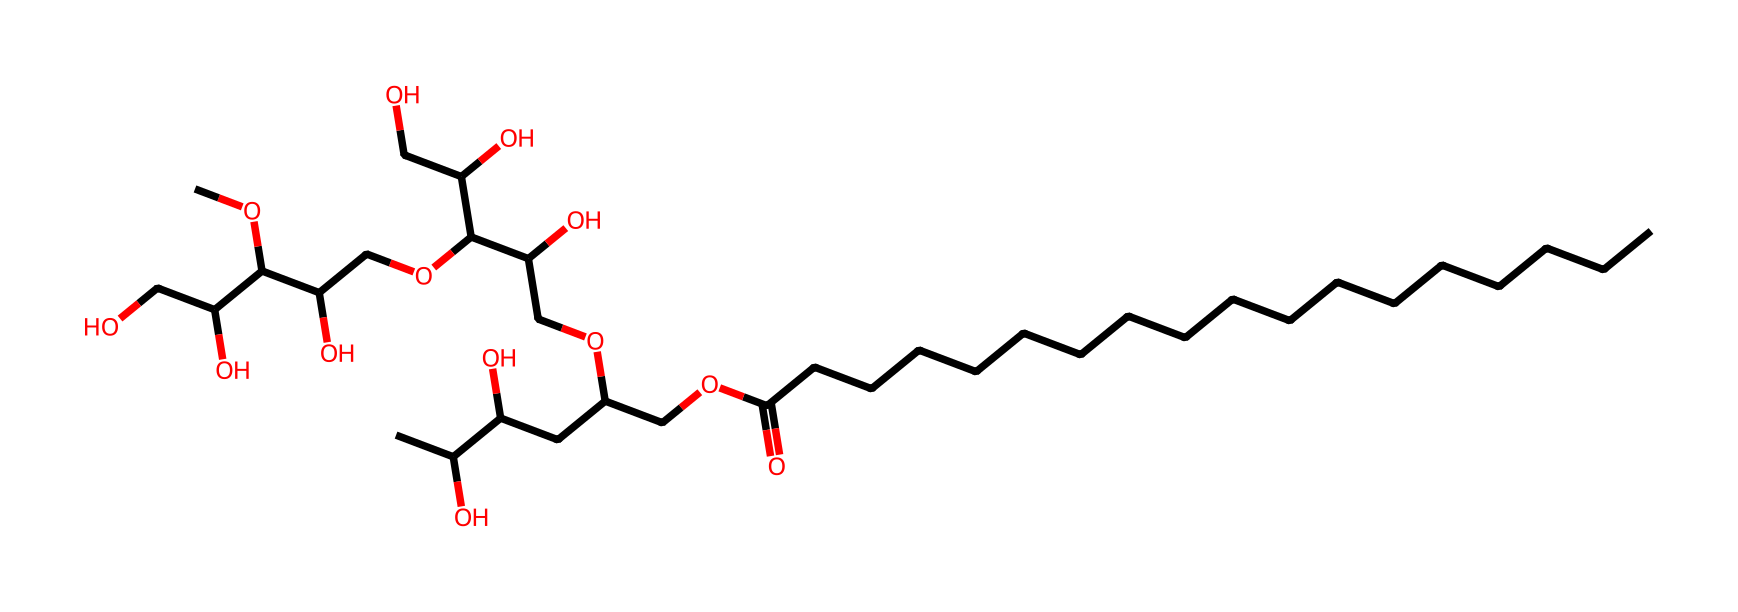What is the molecular formula of polysorbate 80? By analyzing the given SMILES string and accounting for every element present in the structure, we can deduce the molecular formula. The SMILES indicates multiple carbon (C), hydrogen (H), and oxygen (O) atoms throughout. In this case, summing up these atoms gives the final molecular formula C24H44O18.
Answer: C24H44O18 How many ester bonds are present in the structure? The structure of polysorbate 80 contains esters formed between the fatty acid and the glycerol components. By reviewing the SMILES, each segment of the ether linkages (O) in the structure indicates an ester bond. There are 4 ester linkages present.
Answer: 4 What is the primary function of polysorbate 80 in infant formula? Polysorbate 80 is primarily used as an emulsifier in food products, helping to stabilize mixtures of oil and water. This specific function is crucial in infant formula to ensure uniform distribution and absorption of nutrients.
Answer: emulsifier How many carbon atoms are in the longest carbon chain of polysorbate 80? The longest carbon chain can be identified by tracing continuous carbon atoms in the SMILES representation. In this structure, the longest chain stretches across 18 carbon atoms.
Answer: 18 What type of surfactant is polysorbate 80 categorized as? Based on its structure, polysorbate 80 is classified as a nonionic surfactant because it contains no charged functional groups. The presence of hydrophilic (water-attracting) and hydrophobic (water-repelling) parts gives it surfactant properties.
Answer: nonionic How many hydroxyl groups are present in the molecule? In the SMILES structure, each occurrence of 'O' that connects to a carbon in a -OH configuration represents a hydroxyl group. Counting these reveals there are 6 hydroxyl groups within polysorbate 80.
Answer: 6 